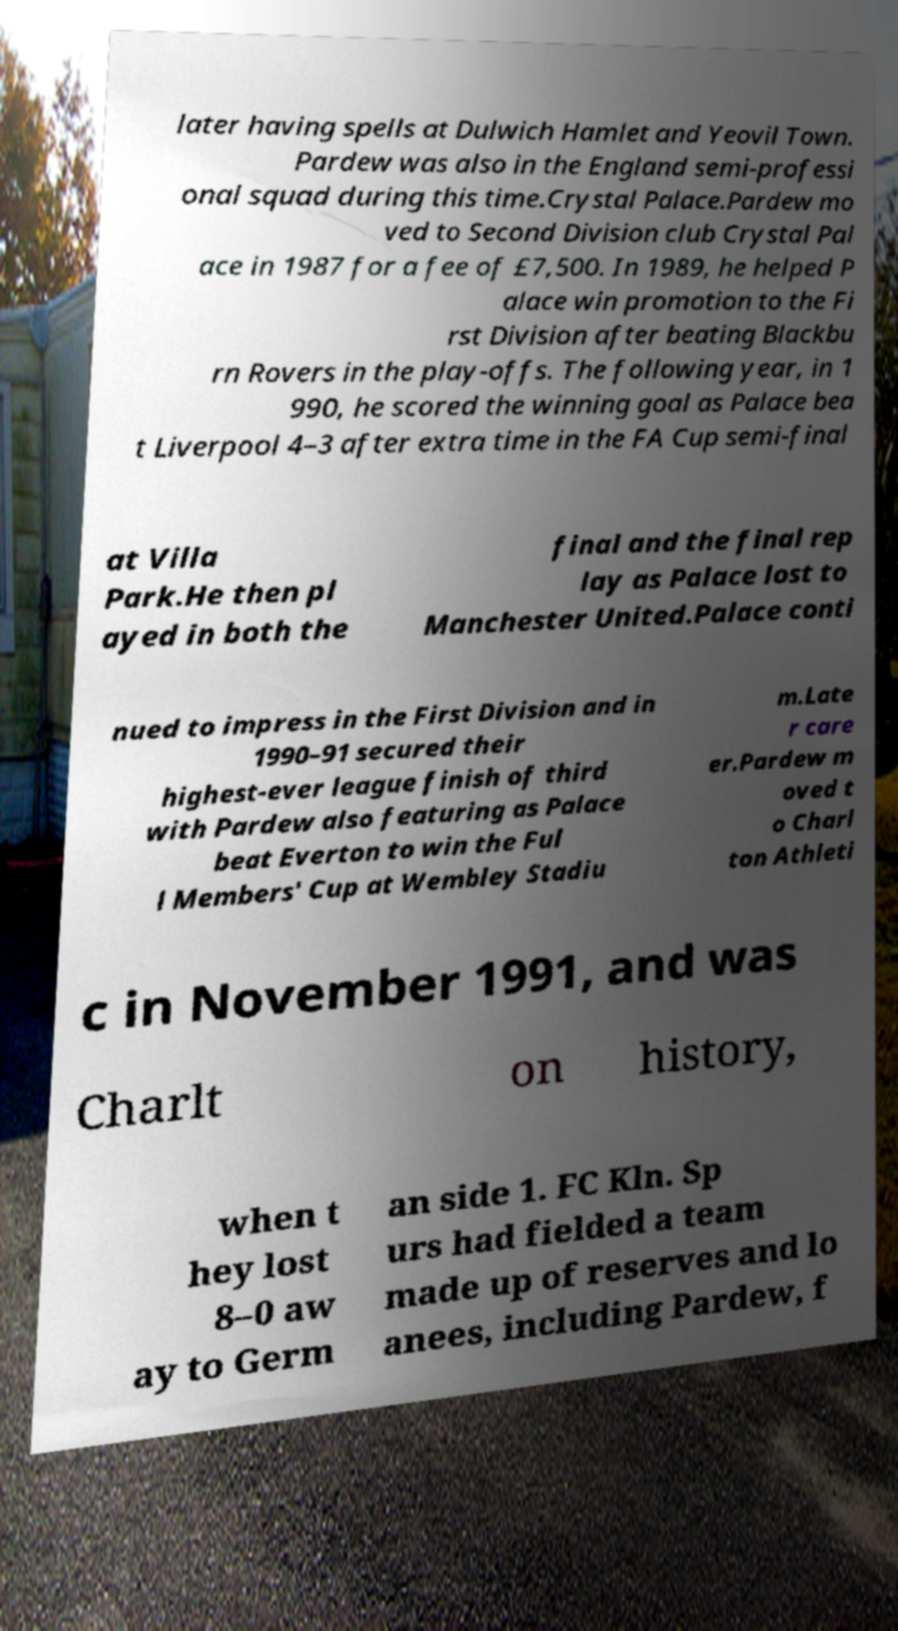There's text embedded in this image that I need extracted. Can you transcribe it verbatim? later having spells at Dulwich Hamlet and Yeovil Town. Pardew was also in the England semi-professi onal squad during this time.Crystal Palace.Pardew mo ved to Second Division club Crystal Pal ace in 1987 for a fee of £7,500. In 1989, he helped P alace win promotion to the Fi rst Division after beating Blackbu rn Rovers in the play-offs. The following year, in 1 990, he scored the winning goal as Palace bea t Liverpool 4–3 after extra time in the FA Cup semi-final at Villa Park.He then pl ayed in both the final and the final rep lay as Palace lost to Manchester United.Palace conti nued to impress in the First Division and in 1990–91 secured their highest-ever league finish of third with Pardew also featuring as Palace beat Everton to win the Ful l Members' Cup at Wembley Stadiu m.Late r care er.Pardew m oved t o Charl ton Athleti c in November 1991, and was Charlt on history, when t hey lost 8–0 aw ay to Germ an side 1. FC Kln. Sp urs had fielded a team made up of reserves and lo anees, including Pardew, f 